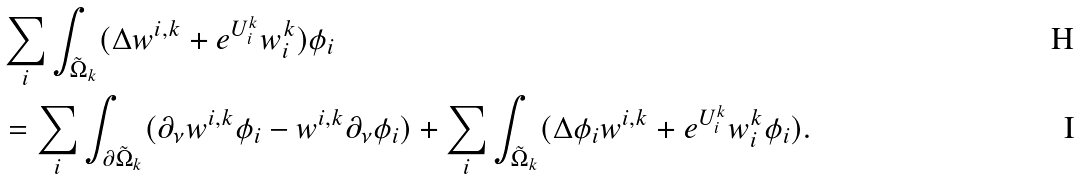Convert formula to latex. <formula><loc_0><loc_0><loc_500><loc_500>& \sum _ { i } \int _ { \tilde { \Omega } _ { k } } ( \Delta w ^ { i , k } + e ^ { U _ { i } ^ { k } } w _ { i } ^ { k } ) \phi _ { i } \\ & = \sum _ { i } \int _ { \partial \tilde { \Omega } _ { k } } ( \partial _ { \nu } w ^ { i , k } \phi _ { i } - w ^ { i , k } \partial _ { \nu } \phi _ { i } ) + \sum _ { i } \int _ { \tilde { \Omega } _ { k } } ( \Delta \phi _ { i } w ^ { i , k } + e ^ { U _ { i } ^ { k } } w _ { i } ^ { k } \phi _ { i } ) .</formula> 